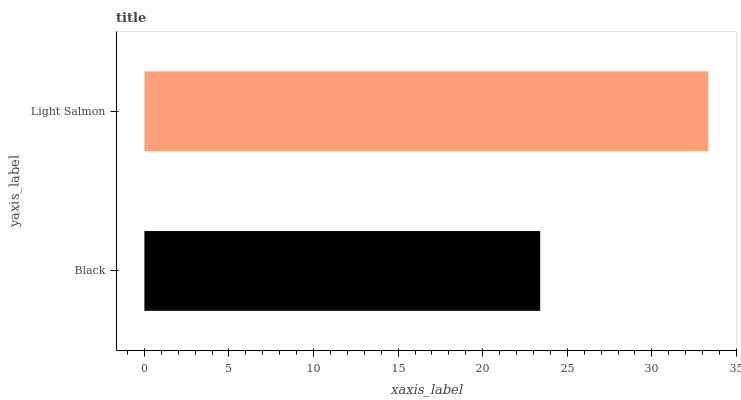Is Black the minimum?
Answer yes or no. Yes. Is Light Salmon the maximum?
Answer yes or no. Yes. Is Light Salmon the minimum?
Answer yes or no. No. Is Light Salmon greater than Black?
Answer yes or no. Yes. Is Black less than Light Salmon?
Answer yes or no. Yes. Is Black greater than Light Salmon?
Answer yes or no. No. Is Light Salmon less than Black?
Answer yes or no. No. Is Light Salmon the high median?
Answer yes or no. Yes. Is Black the low median?
Answer yes or no. Yes. Is Black the high median?
Answer yes or no. No. Is Light Salmon the low median?
Answer yes or no. No. 